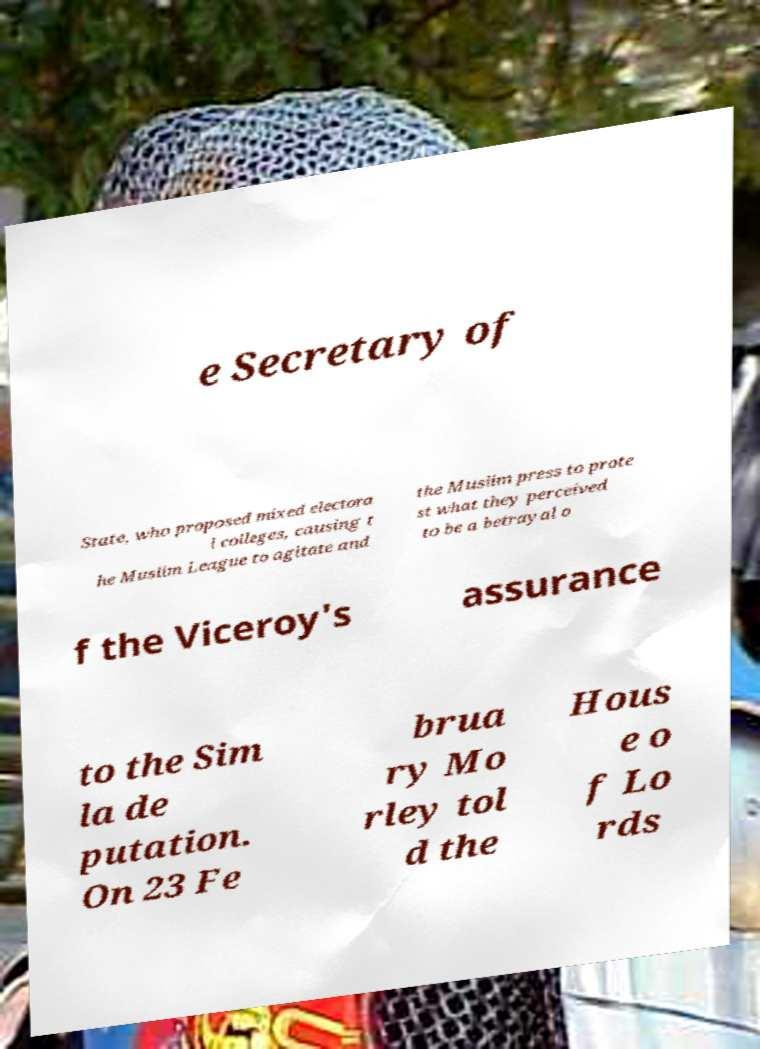What messages or text are displayed in this image? I need them in a readable, typed format. e Secretary of State, who proposed mixed electora l colleges, causing t he Muslim League to agitate and the Muslim press to prote st what they perceived to be a betrayal o f the Viceroy's assurance to the Sim la de putation. On 23 Fe brua ry Mo rley tol d the Hous e o f Lo rds 